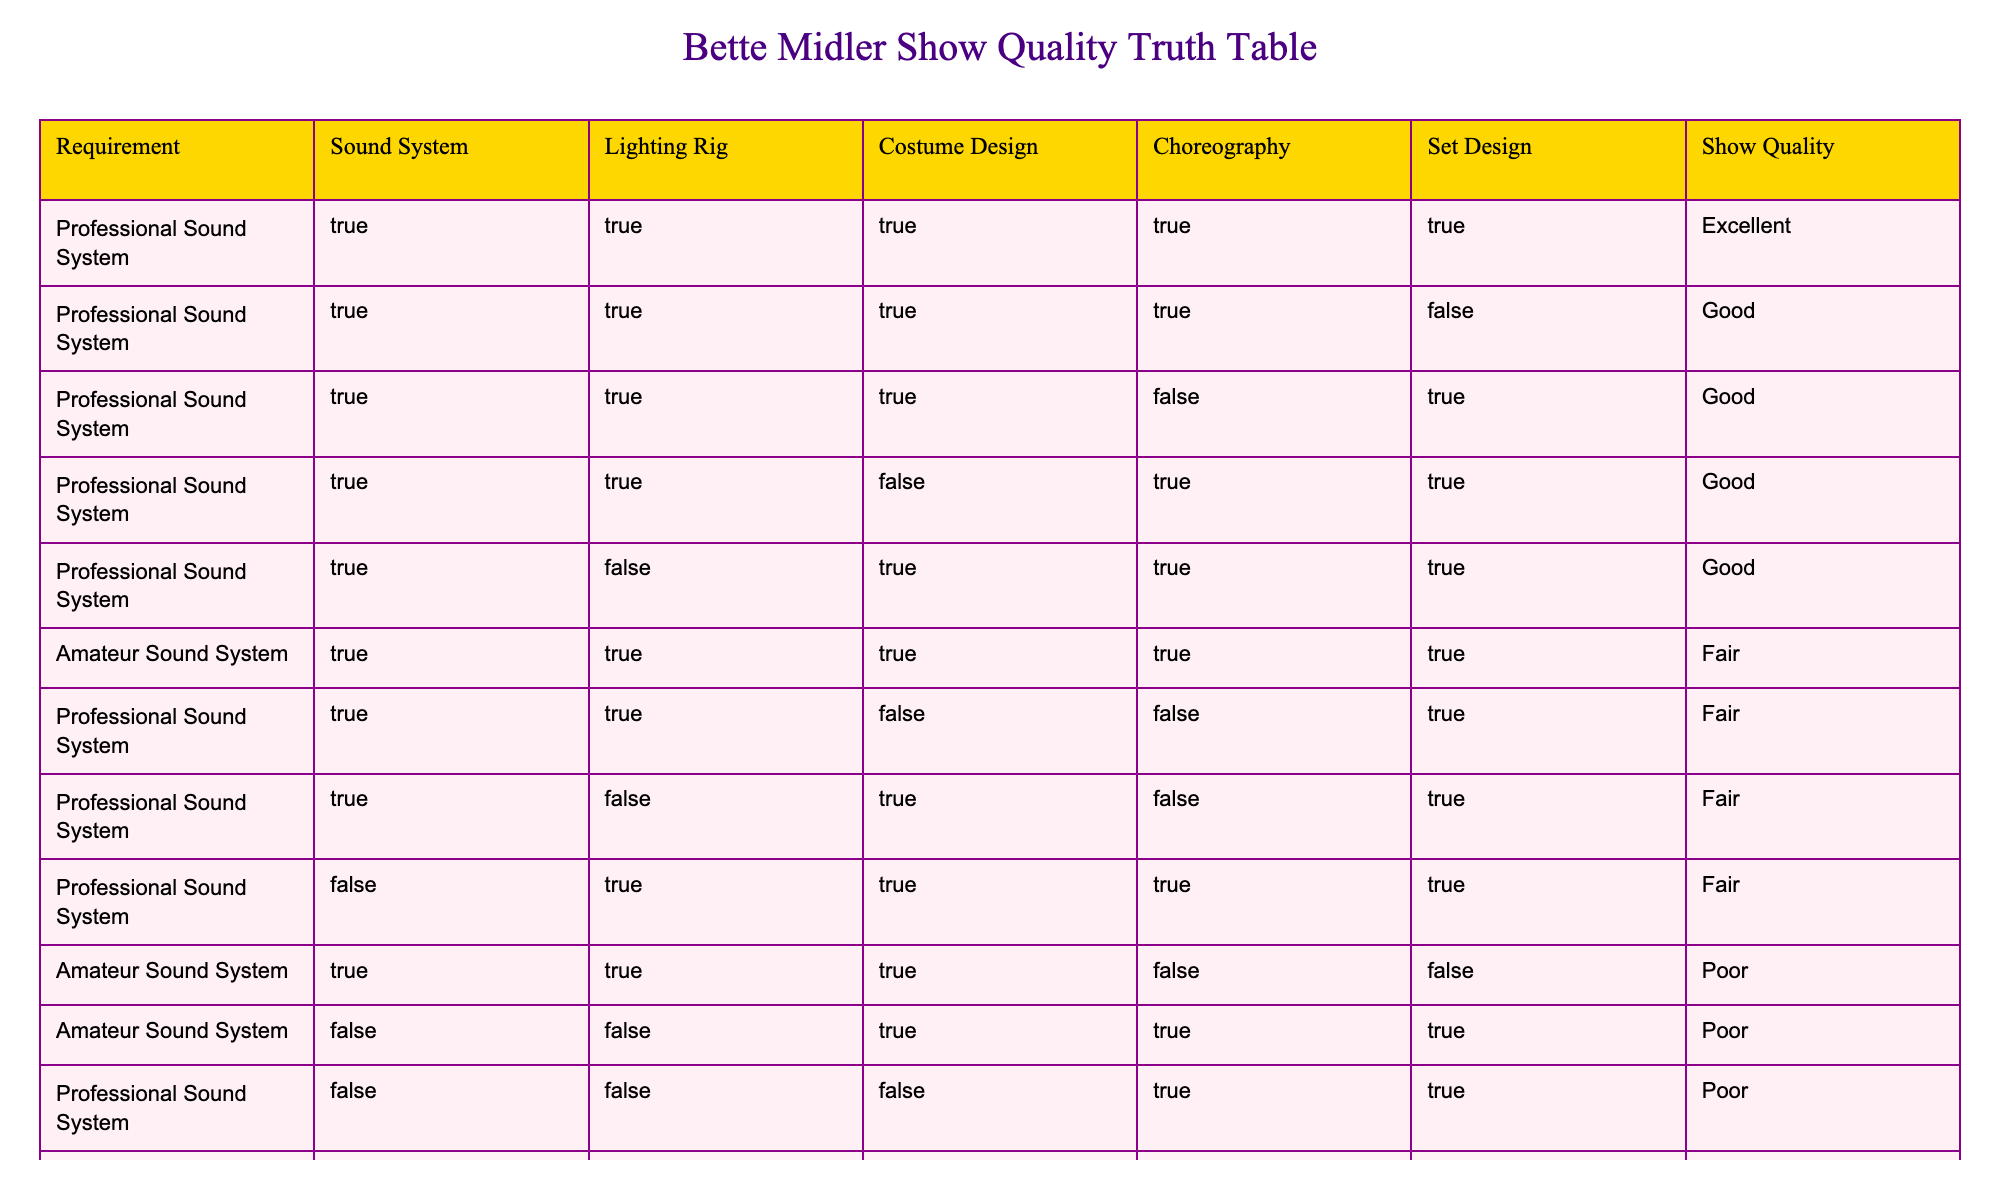What is the show quality associated with a professional sound system and excellent choreography? In the table, look for rows where the requirement is "Professional Sound System" and check the corresponding show quality for rows where "Choreography" is also TRUE. The only matching row has an excellent show quality.
Answer: Excellent How many combinations have a fair show quality? Searching the table, I count the rows that state "Fair" in the "Show Quality" column. There are three rows that meet this criterion.
Answer: 3 Does having a professional sound system guarantee an excellent show quality? Analyzing the table, I see that while a professional sound system is present in several rows, not all yield an excellent show quality. Specifically, the only row that shows "Excellent" also has all other technical requirements fulfilled.
Answer: No What is the impact of a professional sound system on the show quality when the set design is poor? I need to investigate rows with a professional sound system where "Set Design" is marked as FALSE. The show quality in these instances is "Poor," which indicates a strong negative impact from poor set design.
Answer: Negative impact Are there cases where a professional sound system, yet poor costume design leads to fair show quality? I'll scan the table for "Professional Sound System" and "Costume Design" as FALSE. There is a row showing "Fair," confirming this combination can yield fair quality despite one aspect being poor.
Answer: Yes 